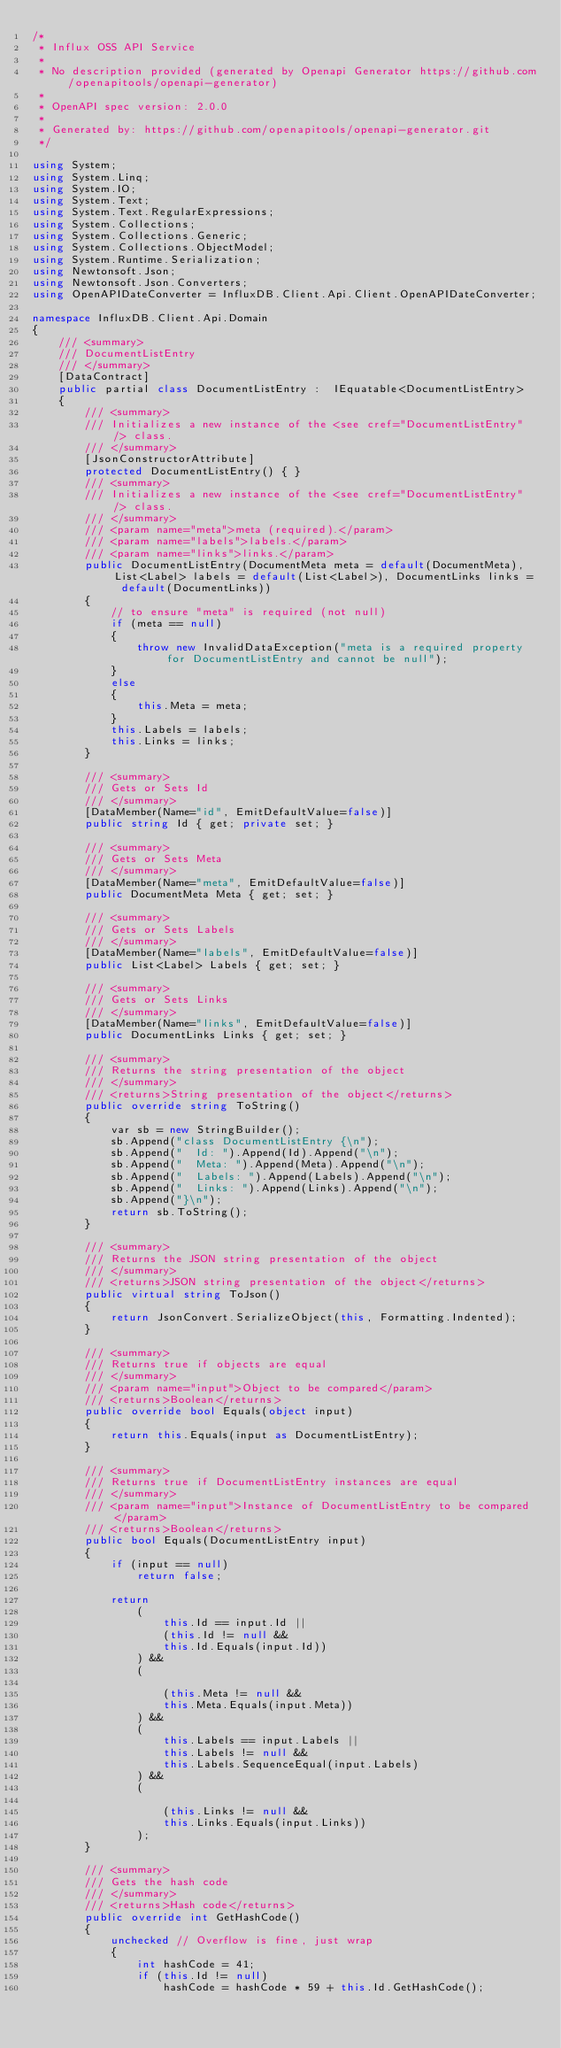<code> <loc_0><loc_0><loc_500><loc_500><_C#_>/* 
 * Influx OSS API Service
 *
 * No description provided (generated by Openapi Generator https://github.com/openapitools/openapi-generator)
 *
 * OpenAPI spec version: 2.0.0
 * 
 * Generated by: https://github.com/openapitools/openapi-generator.git
 */

using System;
using System.Linq;
using System.IO;
using System.Text;
using System.Text.RegularExpressions;
using System.Collections;
using System.Collections.Generic;
using System.Collections.ObjectModel;
using System.Runtime.Serialization;
using Newtonsoft.Json;
using Newtonsoft.Json.Converters;
using OpenAPIDateConverter = InfluxDB.Client.Api.Client.OpenAPIDateConverter;

namespace InfluxDB.Client.Api.Domain
{
    /// <summary>
    /// DocumentListEntry
    /// </summary>
    [DataContract]
    public partial class DocumentListEntry :  IEquatable<DocumentListEntry>
    {
        /// <summary>
        /// Initializes a new instance of the <see cref="DocumentListEntry" /> class.
        /// </summary>
        [JsonConstructorAttribute]
        protected DocumentListEntry() { }
        /// <summary>
        /// Initializes a new instance of the <see cref="DocumentListEntry" /> class.
        /// </summary>
        /// <param name="meta">meta (required).</param>
        /// <param name="labels">labels.</param>
        /// <param name="links">links.</param>
        public DocumentListEntry(DocumentMeta meta = default(DocumentMeta), List<Label> labels = default(List<Label>), DocumentLinks links = default(DocumentLinks))
        {
            // to ensure "meta" is required (not null)
            if (meta == null)
            {
                throw new InvalidDataException("meta is a required property for DocumentListEntry and cannot be null");
            }
            else
            {
                this.Meta = meta;
            }
            this.Labels = labels;
            this.Links = links;
        }

        /// <summary>
        /// Gets or Sets Id
        /// </summary>
        [DataMember(Name="id", EmitDefaultValue=false)]
        public string Id { get; private set; }

        /// <summary>
        /// Gets or Sets Meta
        /// </summary>
        [DataMember(Name="meta", EmitDefaultValue=false)]
        public DocumentMeta Meta { get; set; }

        /// <summary>
        /// Gets or Sets Labels
        /// </summary>
        [DataMember(Name="labels", EmitDefaultValue=false)]
        public List<Label> Labels { get; set; }

        /// <summary>
        /// Gets or Sets Links
        /// </summary>
        [DataMember(Name="links", EmitDefaultValue=false)]
        public DocumentLinks Links { get; set; }

        /// <summary>
        /// Returns the string presentation of the object
        /// </summary>
        /// <returns>String presentation of the object</returns>
        public override string ToString()
        {
            var sb = new StringBuilder();
            sb.Append("class DocumentListEntry {\n");
            sb.Append("  Id: ").Append(Id).Append("\n");
            sb.Append("  Meta: ").Append(Meta).Append("\n");
            sb.Append("  Labels: ").Append(Labels).Append("\n");
            sb.Append("  Links: ").Append(Links).Append("\n");
            sb.Append("}\n");
            return sb.ToString();
        }

        /// <summary>
        /// Returns the JSON string presentation of the object
        /// </summary>
        /// <returns>JSON string presentation of the object</returns>
        public virtual string ToJson()
        {
            return JsonConvert.SerializeObject(this, Formatting.Indented);
        }

        /// <summary>
        /// Returns true if objects are equal
        /// </summary>
        /// <param name="input">Object to be compared</param>
        /// <returns>Boolean</returns>
        public override bool Equals(object input)
        {
            return this.Equals(input as DocumentListEntry);
        }

        /// <summary>
        /// Returns true if DocumentListEntry instances are equal
        /// </summary>
        /// <param name="input">Instance of DocumentListEntry to be compared</param>
        /// <returns>Boolean</returns>
        public bool Equals(DocumentListEntry input)
        {
            if (input == null)
                return false;

            return 
                (
                    this.Id == input.Id ||
                    (this.Id != null &&
                    this.Id.Equals(input.Id))
                ) && 
                (
                    
                    (this.Meta != null &&
                    this.Meta.Equals(input.Meta))
                ) && 
                (
                    this.Labels == input.Labels ||
                    this.Labels != null &&
                    this.Labels.SequenceEqual(input.Labels)
                ) && 
                (
                    
                    (this.Links != null &&
                    this.Links.Equals(input.Links))
                );
        }

        /// <summary>
        /// Gets the hash code
        /// </summary>
        /// <returns>Hash code</returns>
        public override int GetHashCode()
        {
            unchecked // Overflow is fine, just wrap
            {
                int hashCode = 41;
                if (this.Id != null)
                    hashCode = hashCode * 59 + this.Id.GetHashCode();</code> 